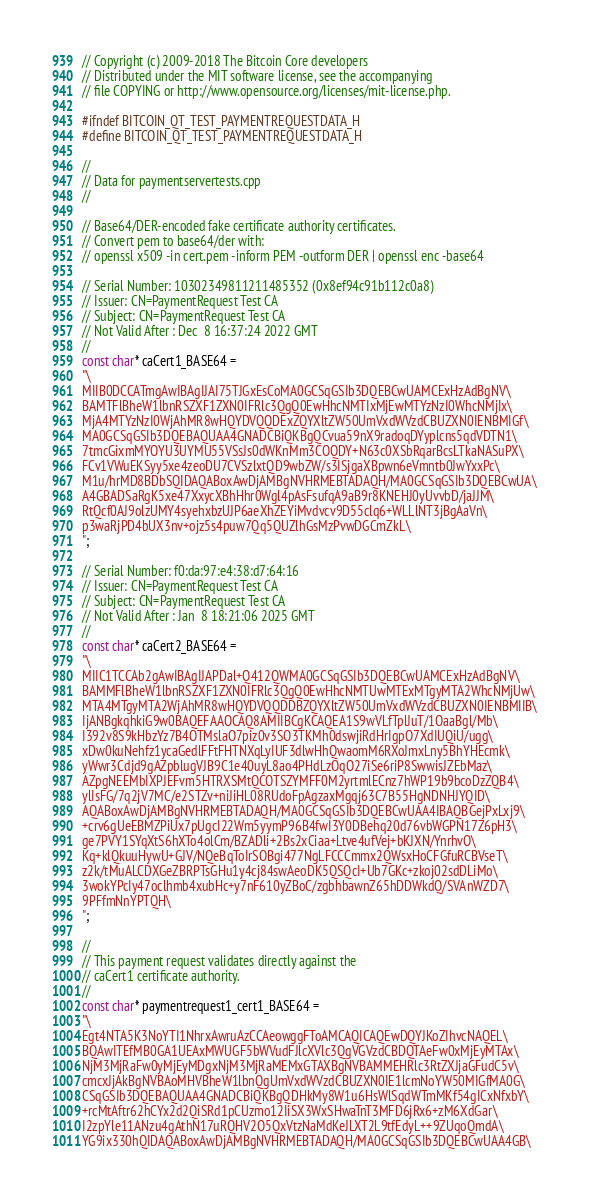Convert code to text. <code><loc_0><loc_0><loc_500><loc_500><_C_>// Copyright (c) 2009-2018 The Bitcoin Core developers
// Distributed under the MIT software license, see the accompanying
// file COPYING or http://www.opensource.org/licenses/mit-license.php.

#ifndef BITCOIN_QT_TEST_PAYMENTREQUESTDATA_H
#define BITCOIN_QT_TEST_PAYMENTREQUESTDATA_H

//
// Data for paymentservertests.cpp
//

// Base64/DER-encoded fake certificate authority certificates.
// Convert pem to base64/der with:
// openssl x509 -in cert.pem -inform PEM -outform DER | openssl enc -base64

// Serial Number: 10302349811211485352 (0x8ef94c91b112c0a8)
// Issuer: CN=PaymentRequest Test CA
// Subject: CN=PaymentRequest Test CA
// Not Valid After : Dec  8 16:37:24 2022 GMT
//
const char* caCert1_BASE64 =
"\
MIIB0DCCATmgAwIBAgIJAI75TJGxEsCoMA0GCSqGSIb3DQEBCwUAMCExHzAdBgNV\
BAMTFlBheW1lbnRSZXF1ZXN0IFRlc3QgQ0EwHhcNMTIxMjEwMTYzNzI0WhcNMjIx\
MjA4MTYzNzI0WjAhMR8wHQYDVQQDExZQYXltZW50UmVxdWVzdCBUZXN0IENBMIGf\
MA0GCSqGSIb3DQEBAQUAA4GNADCBiQKBgQCvua59nX9radoqDYyplcns5qdVDTN1\
7tmcGixmMYOYU3UYMU55VSsJs0dWKnMm3COQDY+N63c0XSbRqarBcsLTkaNASuPX\
FCv1VWuEKSyy5xe4zeoDU7CVSzlxtQD9wbZW/s3ISjgaXBpwn6eVmntb0JwYxxPc\
M1u/hrMD8BDbSQIDAQABoxAwDjAMBgNVHRMEBTADAQH/MA0GCSqGSIb3DQEBCwUA\
A4GBADSaRgK5xe47XxycXBhHhr0Wgl4pAsFsufqA9aB9r8KNEHJ0yUvvbD/jaJJM\
RtQcf0AJ9olzUMY4syehxbzUJP6aeXhZEYiMvdvcv9D55clq6+WLLlNT3jBgAaVn\
p3waRjPD4bUX3nv+ojz5s4puw7Qq5QUZlhGsMzPvwDGCmZkL\
";

// Serial Number: f0:da:97:e4:38:d7:64:16
// Issuer: CN=PaymentRequest Test CA
// Subject: CN=PaymentRequest Test CA
// Not Valid After : Jan  8 18:21:06 2025 GMT
//
const char* caCert2_BASE64 =
"\
MIIC1TCCAb2gAwIBAgIJAPDal+Q412QWMA0GCSqGSIb3DQEBCwUAMCExHzAdBgNV\
BAMMFlBheW1lbnRSZXF1ZXN0IFRlc3QgQ0EwHhcNMTUwMTExMTgyMTA2WhcNMjUw\
MTA4MTgyMTA2WjAhMR8wHQYDVQQDDBZQYXltZW50UmVxdWVzdCBUZXN0IENBMIIB\
IjANBgkqhkiG9w0BAQEFAAOCAQ8AMIIBCgKCAQEA1S9wVLfTplJuT/1OaaBgl/Mb\
I392v8S9kHbzYz7B4OTMslaO7piz0v3SO3TKMh0dswjiRdHrIgpO7XdIUQiU/ugg\
xDw0kuNehfz1ycaGedlFFtFHTNXqLyIUF3dlwHhQwaomM6RXoJmxLny5BhYHEcmk\
yWwr3Cdjd9gAZpblugVJB9C1e40uyL8ao4PHdLzOqO27iSe6riP8SwwisJZEbMaz\
AZpgNEEMbIXPJEFvm5HTRXSMtQCOTSZYMFF0M2yrtmlECnz7hWP19b9bcoDzZQB4\
ylIsFG/7q2jV7MC/e2STZv+niJiHL08RUdoFpAgzaxMgqj63C7B55HgNDNHJYQID\
AQABoxAwDjAMBgNVHRMEBTADAQH/MA0GCSqGSIb3DQEBCwUAA4IBAQBGejPxLxj9\
+crv6gUeEBMZPiUx7pUgcI22Wm5yymP96B4fwI3Y0DBehq20d76vbWGPN17Z6pH3\
ge7PVY1SYqXtS6hXTo4olCm/BZADli+2Bs2xCiaa+Ltve4ufVej+bKJXN/YnrhvO\
Kq+klQkuuHywU+GJV/NQeBqToIrSOBgi477NgLFCCCmmx2QWsxHoCFGfuRCBVseT\
z2k/tMuALCDXGeZBRPTsGHu1y4cj84swAeoDK5QSQcI+Ub7GKc+zkoj02sdDLiMo\
3wokYPcIy47oclhmb4xubHc+y7nF610yZBoC/zgbhbawnZ65hDDWkdQ/SVAnWZD7\
9PFfmNnYPTQH\
";

//
// This payment request validates directly against the
// caCert1 certificate authority.
//
const char* paymentrequest1_cert1_BASE64 =
"\
Egt4NTA5K3NoYTI1NhrxAwruAzCCAeowggFToAMCAQICAQEwDQYJKoZIhvcNAQEL\
BQAwITEfMB0GA1UEAxMWUGF5bWVudFJlcXVlc3QgVGVzdCBDQTAeFw0xMjEyMTAx\
NjM3MjRaFw0yMjEyMDgxNjM3MjRaMEMxGTAXBgNVBAMMEHRlc3RtZXJjaGFudC5v\
cmcxJjAkBgNVBAoMHVBheW1lbnQgUmVxdWVzdCBUZXN0IE1lcmNoYW50MIGfMA0G\
CSqGSIb3DQEBAQUAA4GNADCBiQKBgQDHkMy8W1u6HsWlSqdWTmMKf54gICxNfxbY\
+rcMtAftr62hCYx2d2QiSRd1pCUzmo12IiSX3WxSHwaTnT3MFD6jRx6+zM6XdGar\
I2zpYle11ANzu4gAthN17uRQHV2O5QxVtzNaMdKeJLXT2L9tfEdyL++9ZUqoQmdA\
YG9ix330hQIDAQABoxAwDjAMBgNVHRMEBTADAQH/MA0GCSqGSIb3DQEBCwUAA4GB\</code> 